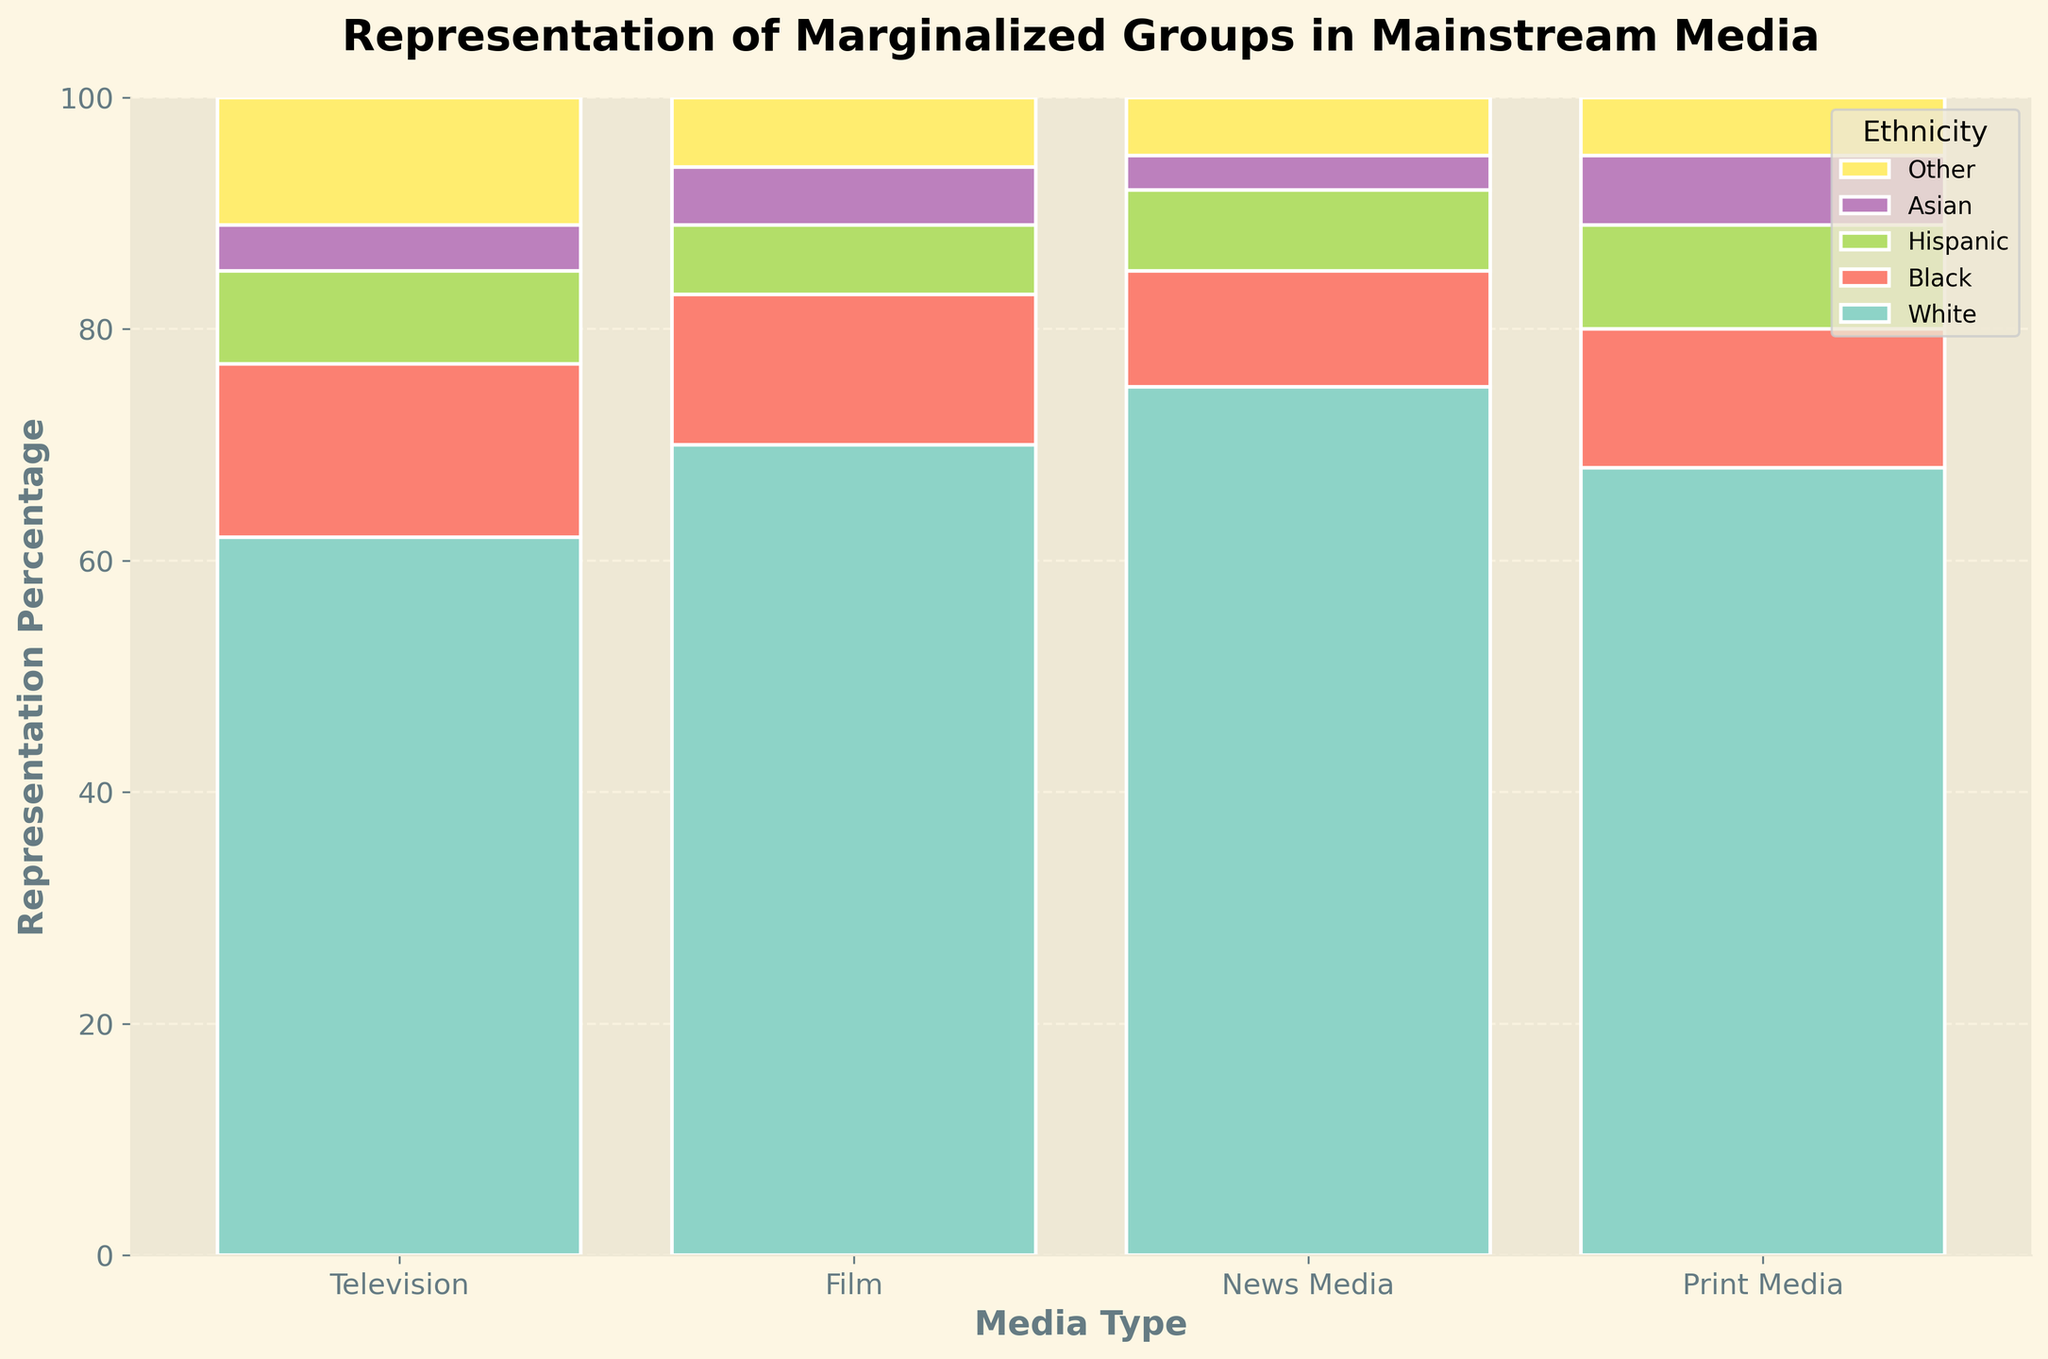what is the ethnicity with the least representation in 'Television'? The smallest value in the 'Television' category is 4%, which corresponds to 'Asian'.
Answer: Asian what is the title of the plot? The title is placed at the top of the plot and indicates the main subject. The title is 'Representation of Marginalized Groups in Mainstream Media'.
Answer: Representation of Marginalized Groups in Mainstream Media how many percentage points higher is the representation of 'White' ethnicity in 'Film' compared to 'Television'? The 'White' representation in 'Film' is 70%, and in 'Television' it is 62%. The difference is 70 - 62 = 8 percentage points.
Answer: 8 which 'Media Type' has the highest representation percentage across all ethnicities? By examining the plot, we see 'News Media' has the highest representation for 'White' ethnicity at 75%. This is higher than all other entries in the plot.
Answer: News Media how does the representation of 'Black' ethnicity compare between 'Print Media' and 'Film'? 'Black' representation in 'Print Media' is 12%, and in 'Film' it is 13%. Comparing these values, 13% is higher than 12%.
Answer: higher in Film what is the combined representation percentage of 'Other' ethnicity across all 'Media Types'? The percentages for 'Other' ethnicity are: Television 11%, Film 6%, News Media 5%, and Print Media 5%. The sum is 11 + 6 + 5 + 5 = 27%.
Answer: 27% what percentage of 'Television' representation does 'Hispanic' ethnicity have compared to 'Print Media'? 'Hispanic' representation in 'Television' is 8%, and in 'Print Media' it is 9%. The percentage is (8/9) × 100 which is approximately 88.89%.
Answer: 88.89% which ethnicity has the closest representation percentage in both 'Television' and 'Print Media'? By comparing the values, 'Asian' representation in 'Television' is 4% and in 'Print Media' is 6%, making it 2 percentage points apart, which is the smallest difference.
Answer: Asian how much more is the 'White' ethnicity represented in 'News Media' compared to 'Film'? The 'White' representation in 'News Media' is 75%, and in 'Film' it is 70%. The difference is 75 - 70 = 5 percentage points.
Answer: 5 which two ethnicities have the most similar representation across 'All Media Types'? Summing up percentages for each ethnicity across all media: 'White' (62+70+75+68=275), 'Black' (15+13+10+12=50), 'Hispanic' (8+6+7+9=30), 'Asian' (4+5+3+6=18), and 'Other' (11+6+5+5=27). Comparing these sums, 'Other' (27%) and 'Asian' (18%) are closest, differing by 9 percentage points.
Answer: Asian and Other 